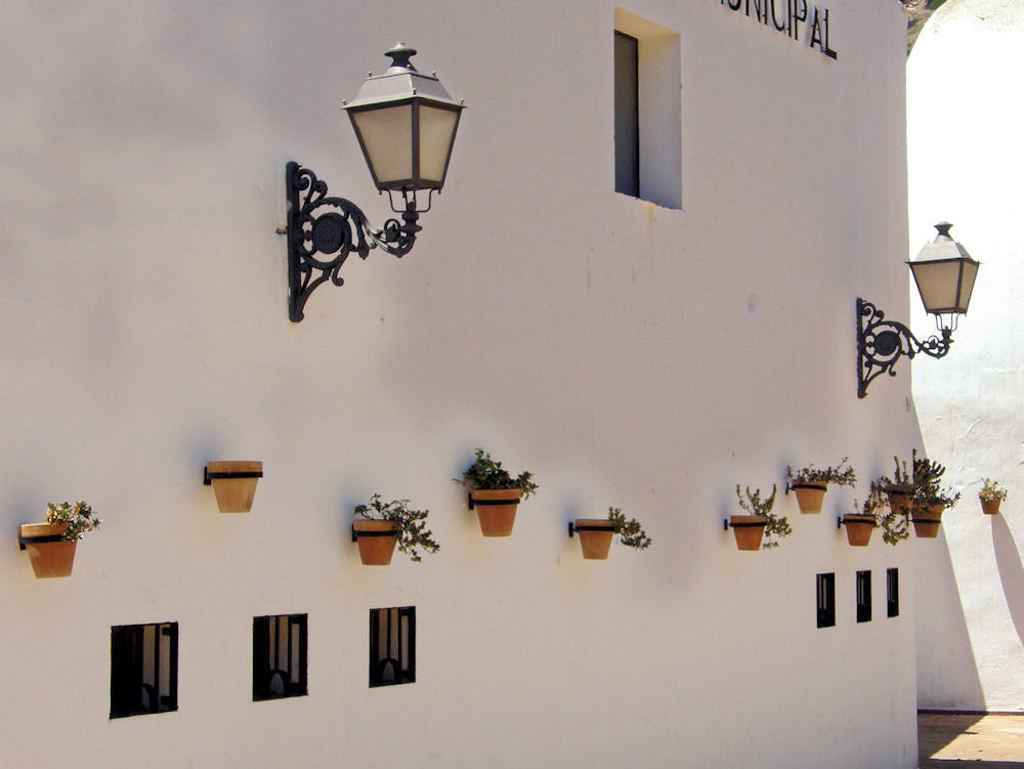What type of structure can be seen in the image? There is a wall in the image. What can be used for cooking in the image? There are grills in the image. What is a source of natural light in the image? There is a window in the image. What type of vegetation is present in the image? There are plants with pots in the image. What can be used for illumination in the image? There are lights in the image. How many sisters are present in the image? There are no sisters present in the image. What type of gold object can be seen in the image? There is no gold object present in the image. 